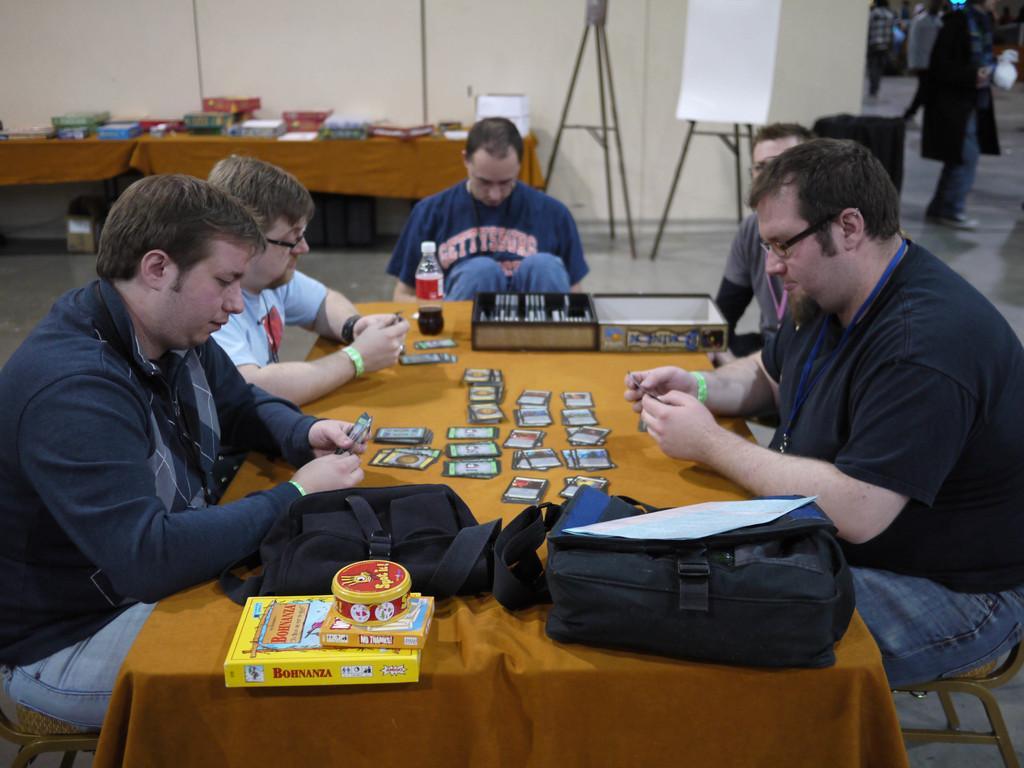How would you summarize this image in a sentence or two? In the center of the image there are people sitting around a table. There are cards, bags and a bottle placed on a table. In the background there is a stand, a board and a wall. On the right side of the image there are people. 